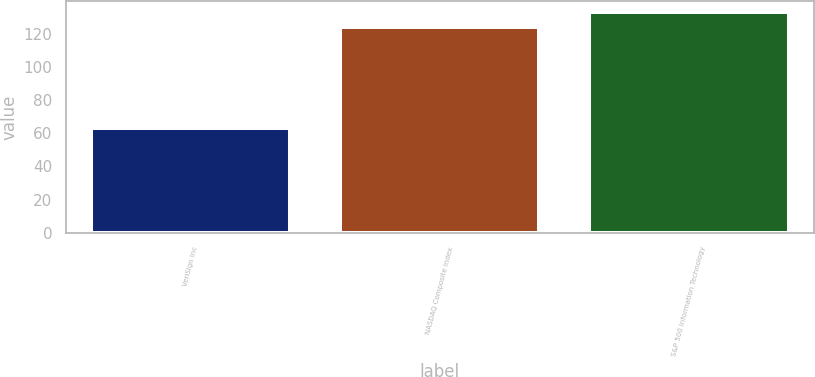Convert chart to OTSL. <chart><loc_0><loc_0><loc_500><loc_500><bar_chart><fcel>VeriSign Inc<fcel>NASDAQ Composite Index<fcel>S&P 500 Information Technology<nl><fcel>63<fcel>124<fcel>133<nl></chart> 